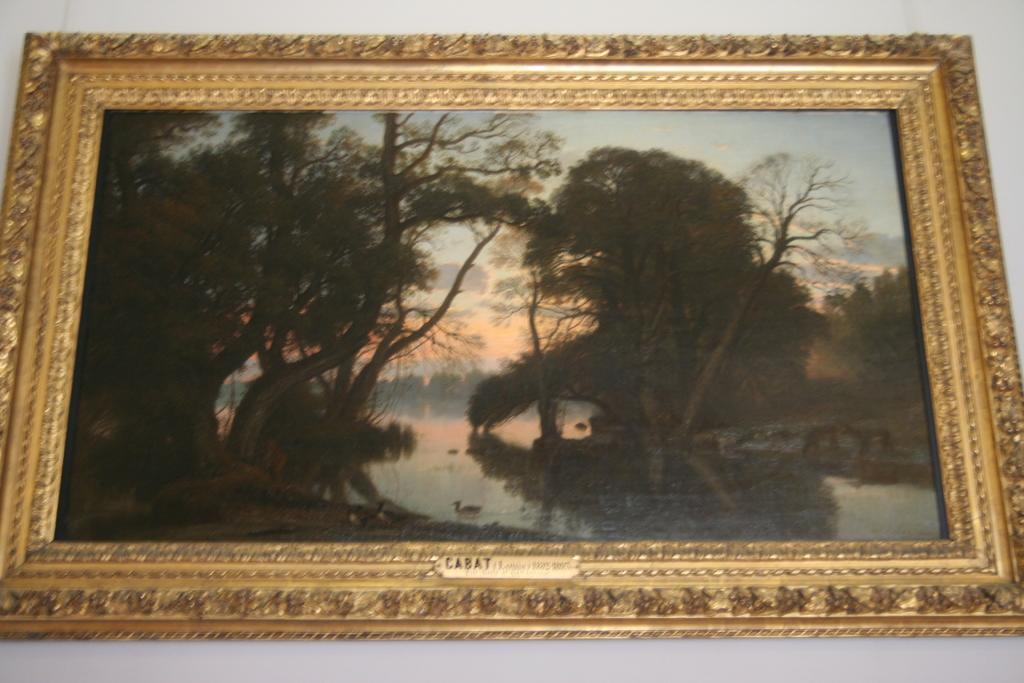Can you describe this image briefly? In this picture we can see a photo frame, in this frame we can see picture of trees, water, a duck and the sky. 